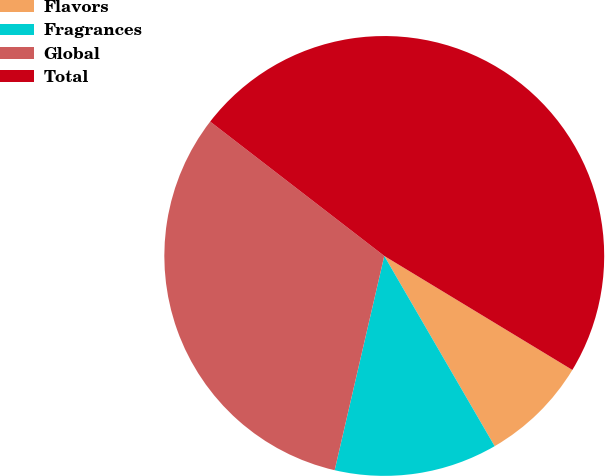<chart> <loc_0><loc_0><loc_500><loc_500><pie_chart><fcel>Flavors<fcel>Fragrances<fcel>Global<fcel>Total<nl><fcel>7.96%<fcel>11.99%<fcel>31.84%<fcel>48.21%<nl></chart> 